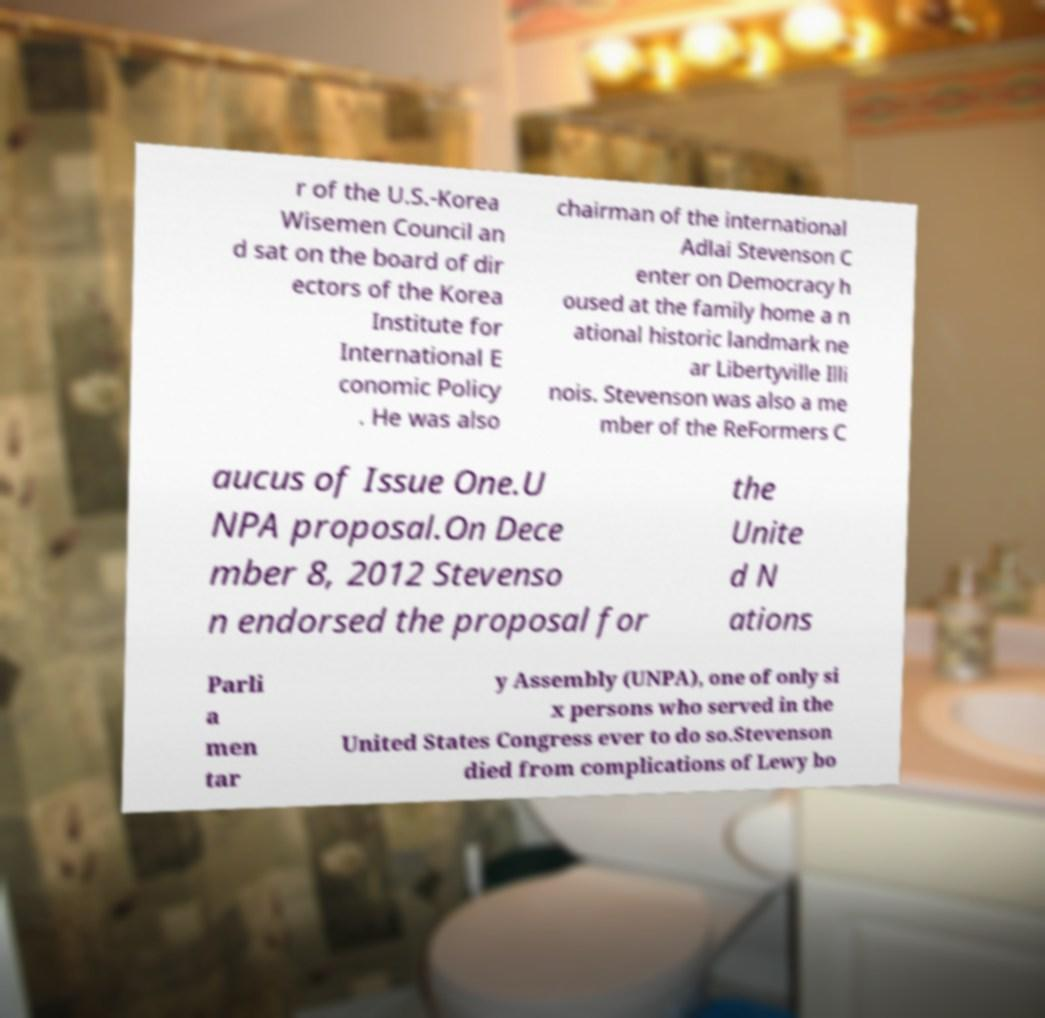Please read and relay the text visible in this image. What does it say? r of the U.S.-Korea Wisemen Council an d sat on the board of dir ectors of the Korea Institute for International E conomic Policy . He was also chairman of the international Adlai Stevenson C enter on Democracy h oused at the family home a n ational historic landmark ne ar Libertyville Illi nois. Stevenson was also a me mber of the ReFormers C aucus of Issue One.U NPA proposal.On Dece mber 8, 2012 Stevenso n endorsed the proposal for the Unite d N ations Parli a men tar y Assembly (UNPA), one of only si x persons who served in the United States Congress ever to do so.Stevenson died from complications of Lewy bo 